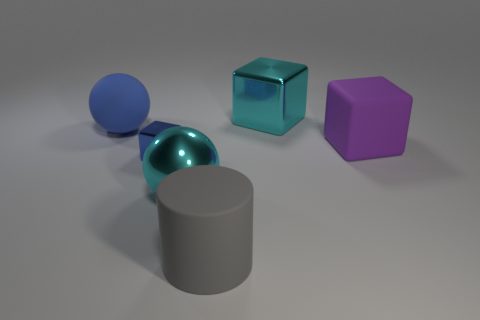Do the cube in front of the large purple object and the large gray cylinder have the same material?
Ensure brevity in your answer.  No. There is a large shiny object that is on the right side of the cyan ball; what is its color?
Ensure brevity in your answer.  Cyan. Is there a matte cylinder that has the same size as the matte sphere?
Your response must be concise. Yes. What is the material of the gray cylinder that is the same size as the metal ball?
Your response must be concise. Rubber. Is the size of the gray matte thing the same as the metal object behind the large purple matte object?
Offer a terse response. Yes. What is the material of the large cyan object that is in front of the big purple matte cube?
Provide a succinct answer. Metal. Are there the same number of tiny cubes that are right of the small blue block and small blue shiny cylinders?
Offer a very short reply. Yes. Do the blue metal block and the metal ball have the same size?
Your response must be concise. No. Are there any matte cylinders behind the cyan thing in front of the blue object behind the blue cube?
Offer a very short reply. No. There is another object that is the same shape as the big blue thing; what material is it?
Ensure brevity in your answer.  Metal. 